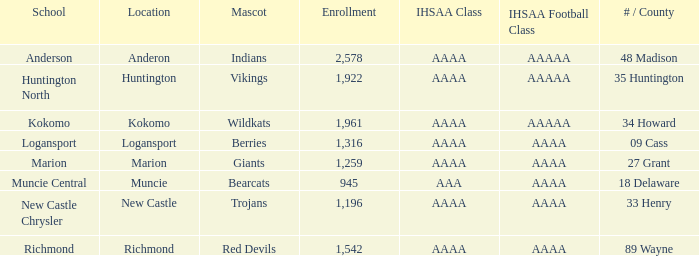What's the least enrolled when the mascot was the Trojans? 1196.0. Would you mind parsing the complete table? {'header': ['School', 'Location', 'Mascot', 'Enrollment', 'IHSAA Class', 'IHSAA Football Class', '# / County'], 'rows': [['Anderson', 'Anderon', 'Indians', '2,578', 'AAAA', 'AAAAA', '48 Madison'], ['Huntington North', 'Huntington', 'Vikings', '1,922', 'AAAA', 'AAAAA', '35 Huntington'], ['Kokomo', 'Kokomo', 'Wildkats', '1,961', 'AAAA', 'AAAAA', '34 Howard'], ['Logansport', 'Logansport', 'Berries', '1,316', 'AAAA', 'AAAA', '09 Cass'], ['Marion', 'Marion', 'Giants', '1,259', 'AAAA', 'AAAA', '27 Grant'], ['Muncie Central', 'Muncie', 'Bearcats', '945', 'AAA', 'AAAA', '18 Delaware'], ['New Castle Chrysler', 'New Castle', 'Trojans', '1,196', 'AAAA', 'AAAA', '33 Henry'], ['Richmond', 'Richmond', 'Red Devils', '1,542', 'AAAA', 'AAAA', '89 Wayne']]} 